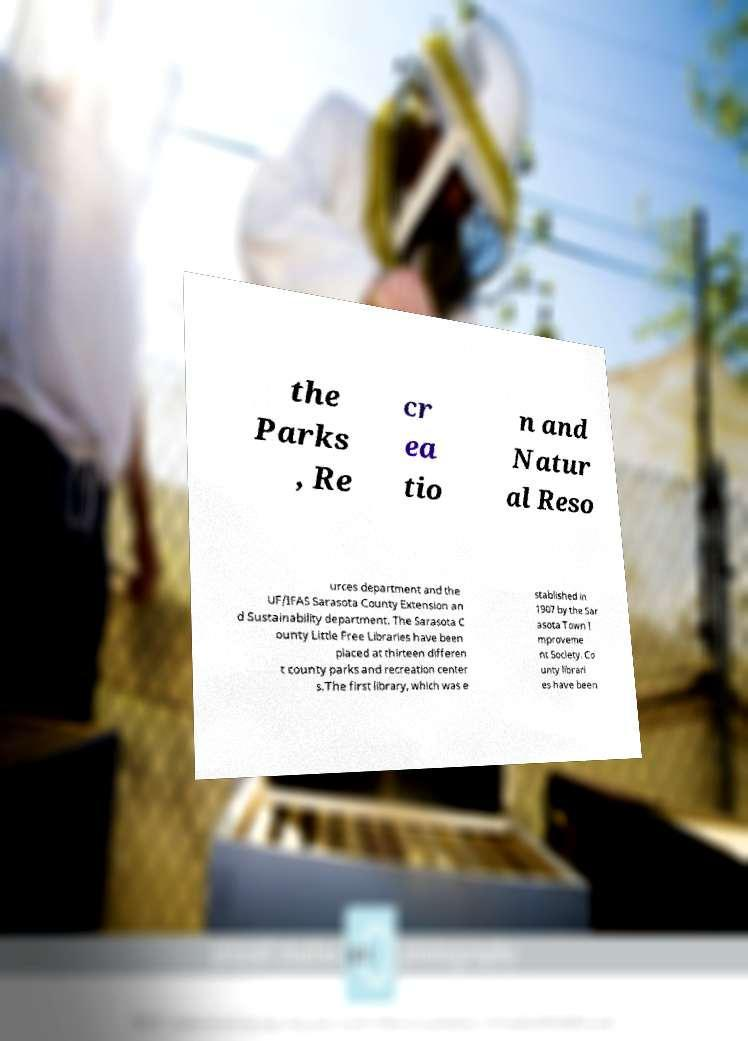Could you extract and type out the text from this image? the Parks , Re cr ea tio n and Natur al Reso urces department and the UF/IFAS Sarasota County Extension an d Sustainability department. The Sarasota C ounty Little Free Libraries have been placed at thirteen differen t county parks and recreation center s.The first library, which was e stablished in 1907 by the Sar asota Town I mproveme nt Society. Co unty librari es have been 